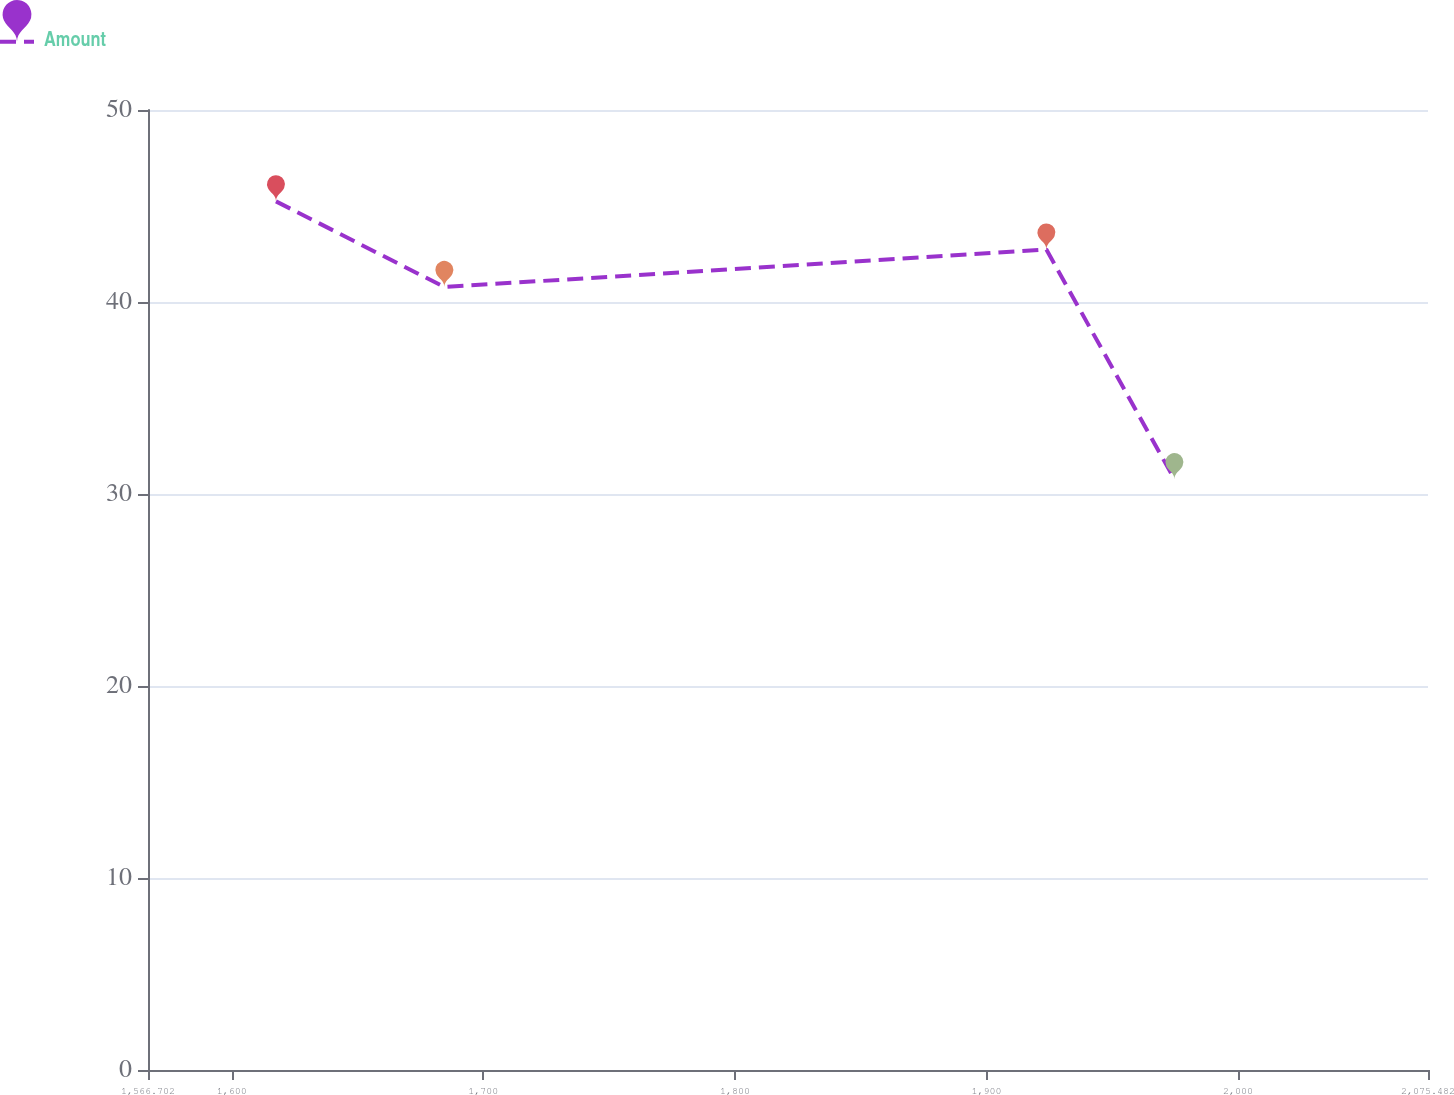<chart> <loc_0><loc_0><loc_500><loc_500><line_chart><ecel><fcel>Amount<nl><fcel>1617.58<fcel>45.24<nl><fcel>1684.5<fcel>40.78<nl><fcel>1923.8<fcel>42.73<nl><fcel>1974.68<fcel>30.77<nl><fcel>2126.36<fcel>25.75<nl></chart> 